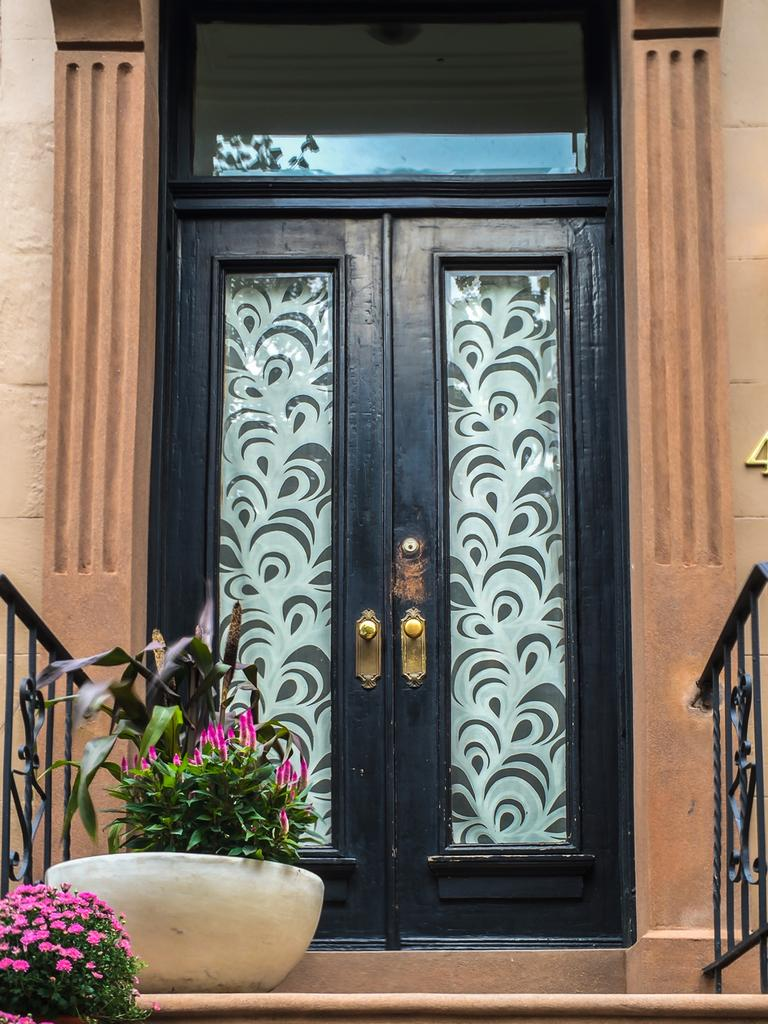What is the main feature in the center of the image? There is a door in the center of the image. What can be seen on the right side of the image? There is a railing and a wall on the right side of the image. What is present on the left side of the image? There are flower pots, plants, and flowers on the left side of the image. What type of leather is visible in the image? There is no leather present in the image. How does the behavior of the plants change during an earthquake in the image? There is no earthquake depicted in the image, and therefore no change in the behavior of the plants can be observed. 